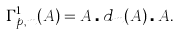Convert formula to latex. <formula><loc_0><loc_0><loc_500><loc_500>\Gamma _ { p , m } ^ { 1 } ( A ) = A \centerdot d _ { m } ( A ) \centerdot A .</formula> 